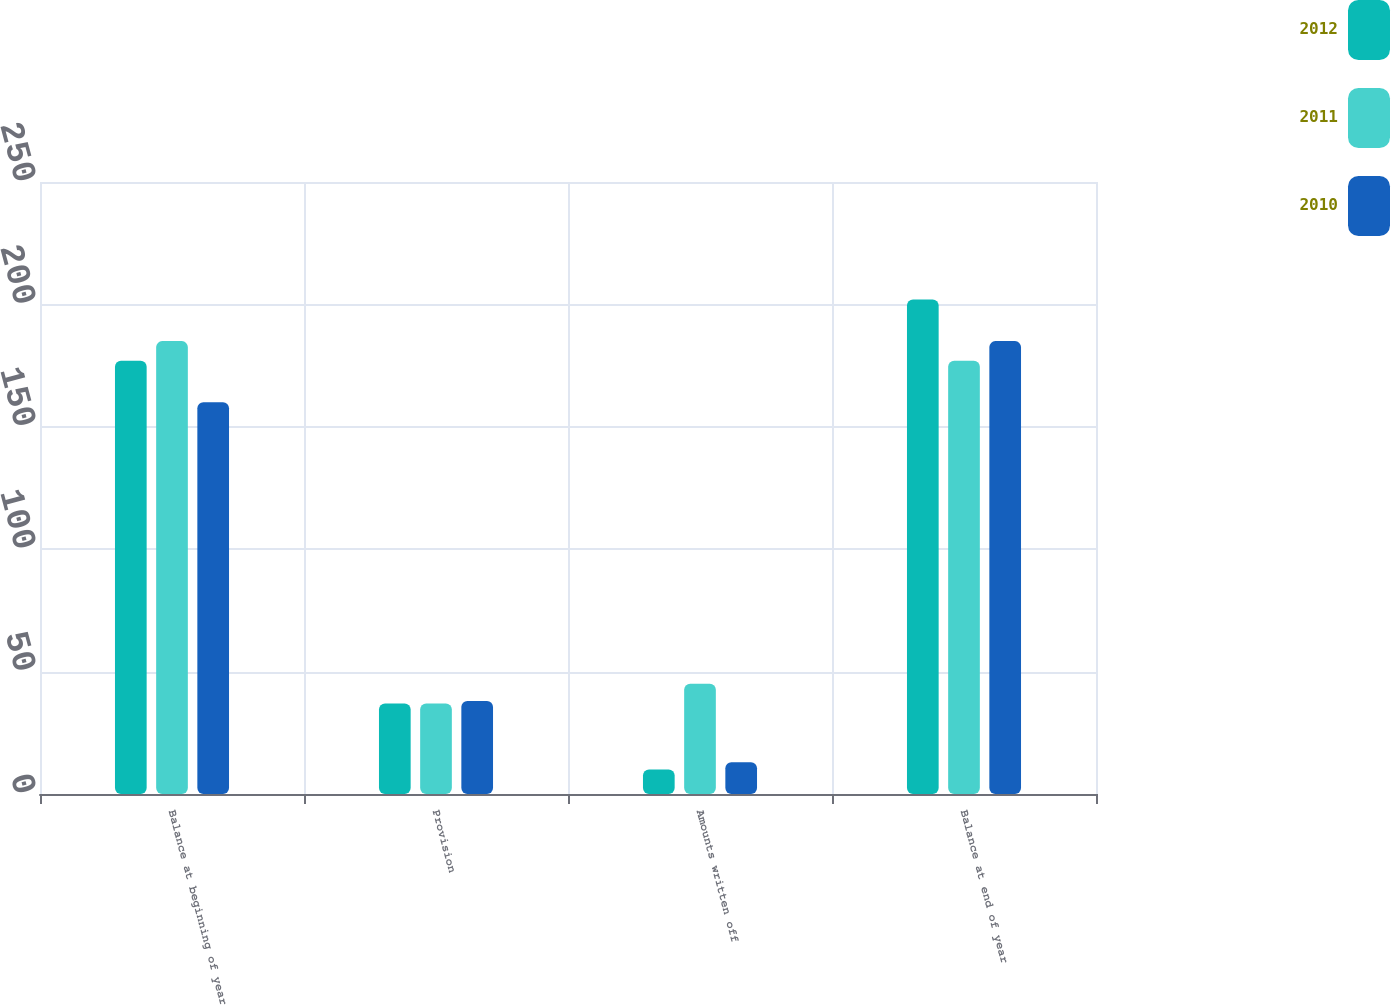Convert chart to OTSL. <chart><loc_0><loc_0><loc_500><loc_500><stacked_bar_chart><ecel><fcel>Balance at beginning of year<fcel>Provision<fcel>Amounts written off<fcel>Balance at end of year<nl><fcel>2012<fcel>177<fcel>37<fcel>10<fcel>202<nl><fcel>2011<fcel>185<fcel>37<fcel>45<fcel>177<nl><fcel>2010<fcel>160<fcel>38<fcel>13<fcel>185<nl></chart> 